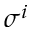<formula> <loc_0><loc_0><loc_500><loc_500>\sigma ^ { i }</formula> 